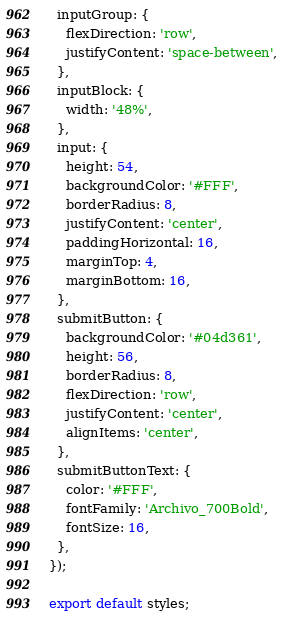<code> <loc_0><loc_0><loc_500><loc_500><_TypeScript_>  inputGroup: {
    flexDirection: 'row',
    justifyContent: 'space-between',
  },
  inputBlock: {
    width: '48%',
  },
  input: {
    height: 54,
    backgroundColor: '#FFF',
    borderRadius: 8,
    justifyContent: 'center',
    paddingHorizontal: 16,
    marginTop: 4,
    marginBottom: 16,
  },
  submitButton: {
    backgroundColor: '#04d361',
    height: 56,
    borderRadius: 8,
    flexDirection: 'row',
    justifyContent: 'center',
    alignItems: 'center',
  },
  submitButtonText: {
    color: '#FFF',
    fontFamily: 'Archivo_700Bold',
    fontSize: 16,
  },
});

export default styles;
</code> 